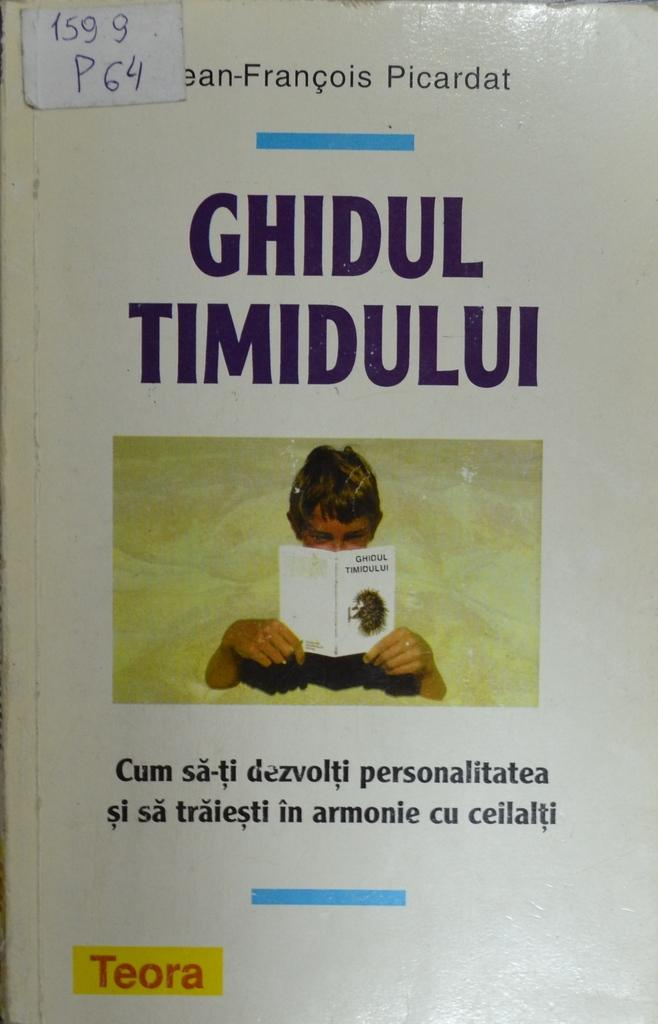<image>
Relay a brief, clear account of the picture shown. the cover of book Ghidul Timidului by Picardat 